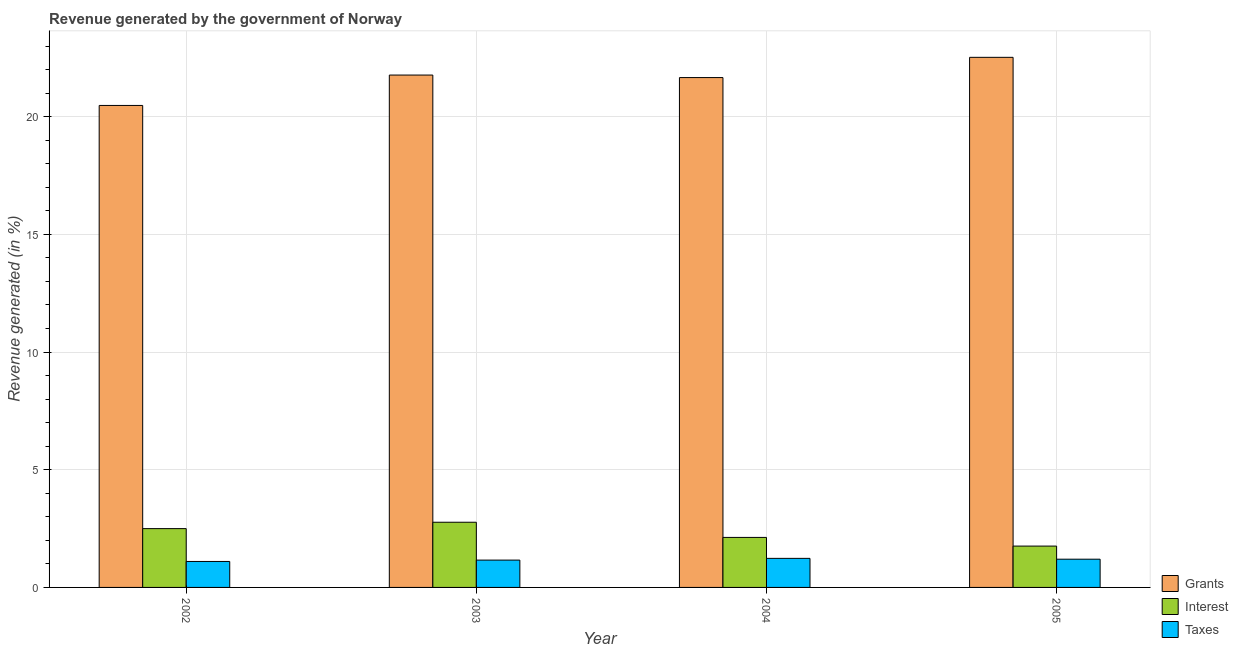How many different coloured bars are there?
Keep it short and to the point. 3. What is the label of the 1st group of bars from the left?
Make the answer very short. 2002. In how many cases, is the number of bars for a given year not equal to the number of legend labels?
Provide a succinct answer. 0. What is the percentage of revenue generated by grants in 2002?
Give a very brief answer. 20.48. Across all years, what is the maximum percentage of revenue generated by grants?
Ensure brevity in your answer.  22.52. Across all years, what is the minimum percentage of revenue generated by taxes?
Offer a very short reply. 1.1. In which year was the percentage of revenue generated by taxes minimum?
Your response must be concise. 2002. What is the total percentage of revenue generated by grants in the graph?
Give a very brief answer. 86.44. What is the difference between the percentage of revenue generated by taxes in 2004 and that in 2005?
Your response must be concise. 0.04. What is the difference between the percentage of revenue generated by interest in 2002 and the percentage of revenue generated by grants in 2004?
Your response must be concise. 0.37. What is the average percentage of revenue generated by taxes per year?
Provide a short and direct response. 1.17. In the year 2003, what is the difference between the percentage of revenue generated by grants and percentage of revenue generated by interest?
Ensure brevity in your answer.  0. What is the ratio of the percentage of revenue generated by grants in 2003 to that in 2004?
Your answer should be compact. 1. Is the percentage of revenue generated by grants in 2002 less than that in 2004?
Your answer should be compact. Yes. What is the difference between the highest and the second highest percentage of revenue generated by taxes?
Offer a terse response. 0.04. What is the difference between the highest and the lowest percentage of revenue generated by interest?
Provide a short and direct response. 1.01. What does the 3rd bar from the left in 2002 represents?
Your answer should be very brief. Taxes. What does the 2nd bar from the right in 2002 represents?
Ensure brevity in your answer.  Interest. How many bars are there?
Offer a very short reply. 12. Are the values on the major ticks of Y-axis written in scientific E-notation?
Make the answer very short. No. Does the graph contain any zero values?
Keep it short and to the point. No. Does the graph contain grids?
Provide a short and direct response. Yes. Where does the legend appear in the graph?
Ensure brevity in your answer.  Bottom right. How many legend labels are there?
Give a very brief answer. 3. What is the title of the graph?
Your answer should be compact. Revenue generated by the government of Norway. Does "Methane" appear as one of the legend labels in the graph?
Provide a short and direct response. No. What is the label or title of the X-axis?
Provide a succinct answer. Year. What is the label or title of the Y-axis?
Give a very brief answer. Revenue generated (in %). What is the Revenue generated (in %) in Grants in 2002?
Provide a short and direct response. 20.48. What is the Revenue generated (in %) in Interest in 2002?
Offer a terse response. 2.5. What is the Revenue generated (in %) in Taxes in 2002?
Your answer should be very brief. 1.1. What is the Revenue generated (in %) of Grants in 2003?
Give a very brief answer. 21.77. What is the Revenue generated (in %) of Interest in 2003?
Give a very brief answer. 2.77. What is the Revenue generated (in %) in Taxes in 2003?
Make the answer very short. 1.16. What is the Revenue generated (in %) in Grants in 2004?
Provide a succinct answer. 21.66. What is the Revenue generated (in %) in Interest in 2004?
Your response must be concise. 2.13. What is the Revenue generated (in %) of Taxes in 2004?
Provide a succinct answer. 1.23. What is the Revenue generated (in %) of Grants in 2005?
Keep it short and to the point. 22.52. What is the Revenue generated (in %) in Interest in 2005?
Your response must be concise. 1.76. What is the Revenue generated (in %) in Taxes in 2005?
Give a very brief answer. 1.2. Across all years, what is the maximum Revenue generated (in %) in Grants?
Your answer should be very brief. 22.52. Across all years, what is the maximum Revenue generated (in %) of Interest?
Offer a terse response. 2.77. Across all years, what is the maximum Revenue generated (in %) of Taxes?
Offer a terse response. 1.23. Across all years, what is the minimum Revenue generated (in %) of Grants?
Provide a short and direct response. 20.48. Across all years, what is the minimum Revenue generated (in %) in Interest?
Give a very brief answer. 1.76. Across all years, what is the minimum Revenue generated (in %) in Taxes?
Offer a very short reply. 1.1. What is the total Revenue generated (in %) of Grants in the graph?
Make the answer very short. 86.44. What is the total Revenue generated (in %) of Interest in the graph?
Ensure brevity in your answer.  9.15. What is the total Revenue generated (in %) in Taxes in the graph?
Offer a very short reply. 4.7. What is the difference between the Revenue generated (in %) of Grants in 2002 and that in 2003?
Your answer should be compact. -1.29. What is the difference between the Revenue generated (in %) of Interest in 2002 and that in 2003?
Make the answer very short. -0.27. What is the difference between the Revenue generated (in %) of Taxes in 2002 and that in 2003?
Keep it short and to the point. -0.06. What is the difference between the Revenue generated (in %) in Grants in 2002 and that in 2004?
Ensure brevity in your answer.  -1.18. What is the difference between the Revenue generated (in %) in Interest in 2002 and that in 2004?
Provide a short and direct response. 0.37. What is the difference between the Revenue generated (in %) in Taxes in 2002 and that in 2004?
Offer a terse response. -0.13. What is the difference between the Revenue generated (in %) in Grants in 2002 and that in 2005?
Provide a short and direct response. -2.04. What is the difference between the Revenue generated (in %) in Interest in 2002 and that in 2005?
Provide a short and direct response. 0.74. What is the difference between the Revenue generated (in %) of Taxes in 2002 and that in 2005?
Your answer should be compact. -0.1. What is the difference between the Revenue generated (in %) in Grants in 2003 and that in 2004?
Give a very brief answer. 0.11. What is the difference between the Revenue generated (in %) of Interest in 2003 and that in 2004?
Make the answer very short. 0.64. What is the difference between the Revenue generated (in %) of Taxes in 2003 and that in 2004?
Provide a succinct answer. -0.07. What is the difference between the Revenue generated (in %) in Grants in 2003 and that in 2005?
Your answer should be compact. -0.75. What is the difference between the Revenue generated (in %) in Taxes in 2003 and that in 2005?
Your answer should be very brief. -0.04. What is the difference between the Revenue generated (in %) in Grants in 2004 and that in 2005?
Provide a succinct answer. -0.86. What is the difference between the Revenue generated (in %) in Interest in 2004 and that in 2005?
Keep it short and to the point. 0.37. What is the difference between the Revenue generated (in %) in Taxes in 2004 and that in 2005?
Offer a terse response. 0.04. What is the difference between the Revenue generated (in %) of Grants in 2002 and the Revenue generated (in %) of Interest in 2003?
Keep it short and to the point. 17.71. What is the difference between the Revenue generated (in %) in Grants in 2002 and the Revenue generated (in %) in Taxes in 2003?
Your answer should be compact. 19.32. What is the difference between the Revenue generated (in %) of Interest in 2002 and the Revenue generated (in %) of Taxes in 2003?
Give a very brief answer. 1.34. What is the difference between the Revenue generated (in %) in Grants in 2002 and the Revenue generated (in %) in Interest in 2004?
Provide a succinct answer. 18.35. What is the difference between the Revenue generated (in %) in Grants in 2002 and the Revenue generated (in %) in Taxes in 2004?
Make the answer very short. 19.24. What is the difference between the Revenue generated (in %) in Interest in 2002 and the Revenue generated (in %) in Taxes in 2004?
Provide a succinct answer. 1.26. What is the difference between the Revenue generated (in %) in Grants in 2002 and the Revenue generated (in %) in Interest in 2005?
Make the answer very short. 18.72. What is the difference between the Revenue generated (in %) of Grants in 2002 and the Revenue generated (in %) of Taxes in 2005?
Your answer should be compact. 19.28. What is the difference between the Revenue generated (in %) in Interest in 2002 and the Revenue generated (in %) in Taxes in 2005?
Offer a very short reply. 1.3. What is the difference between the Revenue generated (in %) in Grants in 2003 and the Revenue generated (in %) in Interest in 2004?
Make the answer very short. 19.64. What is the difference between the Revenue generated (in %) in Grants in 2003 and the Revenue generated (in %) in Taxes in 2004?
Make the answer very short. 20.54. What is the difference between the Revenue generated (in %) in Interest in 2003 and the Revenue generated (in %) in Taxes in 2004?
Make the answer very short. 1.54. What is the difference between the Revenue generated (in %) of Grants in 2003 and the Revenue generated (in %) of Interest in 2005?
Make the answer very short. 20.01. What is the difference between the Revenue generated (in %) of Grants in 2003 and the Revenue generated (in %) of Taxes in 2005?
Provide a succinct answer. 20.57. What is the difference between the Revenue generated (in %) of Interest in 2003 and the Revenue generated (in %) of Taxes in 2005?
Your response must be concise. 1.57. What is the difference between the Revenue generated (in %) of Grants in 2004 and the Revenue generated (in %) of Interest in 2005?
Keep it short and to the point. 19.91. What is the difference between the Revenue generated (in %) in Grants in 2004 and the Revenue generated (in %) in Taxes in 2005?
Your response must be concise. 20.46. What is the difference between the Revenue generated (in %) of Interest in 2004 and the Revenue generated (in %) of Taxes in 2005?
Your answer should be compact. 0.93. What is the average Revenue generated (in %) of Grants per year?
Offer a very short reply. 21.61. What is the average Revenue generated (in %) of Interest per year?
Ensure brevity in your answer.  2.29. What is the average Revenue generated (in %) in Taxes per year?
Ensure brevity in your answer.  1.17. In the year 2002, what is the difference between the Revenue generated (in %) of Grants and Revenue generated (in %) of Interest?
Offer a terse response. 17.98. In the year 2002, what is the difference between the Revenue generated (in %) of Grants and Revenue generated (in %) of Taxes?
Offer a terse response. 19.38. In the year 2002, what is the difference between the Revenue generated (in %) of Interest and Revenue generated (in %) of Taxes?
Provide a short and direct response. 1.4. In the year 2003, what is the difference between the Revenue generated (in %) of Grants and Revenue generated (in %) of Interest?
Your answer should be very brief. 19. In the year 2003, what is the difference between the Revenue generated (in %) in Grants and Revenue generated (in %) in Taxes?
Provide a succinct answer. 20.61. In the year 2003, what is the difference between the Revenue generated (in %) in Interest and Revenue generated (in %) in Taxes?
Keep it short and to the point. 1.61. In the year 2004, what is the difference between the Revenue generated (in %) in Grants and Revenue generated (in %) in Interest?
Your answer should be very brief. 19.54. In the year 2004, what is the difference between the Revenue generated (in %) of Grants and Revenue generated (in %) of Taxes?
Provide a succinct answer. 20.43. In the year 2004, what is the difference between the Revenue generated (in %) in Interest and Revenue generated (in %) in Taxes?
Ensure brevity in your answer.  0.89. In the year 2005, what is the difference between the Revenue generated (in %) in Grants and Revenue generated (in %) in Interest?
Provide a short and direct response. 20.77. In the year 2005, what is the difference between the Revenue generated (in %) of Grants and Revenue generated (in %) of Taxes?
Make the answer very short. 21.32. In the year 2005, what is the difference between the Revenue generated (in %) of Interest and Revenue generated (in %) of Taxes?
Your answer should be compact. 0.56. What is the ratio of the Revenue generated (in %) of Grants in 2002 to that in 2003?
Offer a terse response. 0.94. What is the ratio of the Revenue generated (in %) in Interest in 2002 to that in 2003?
Your answer should be compact. 0.9. What is the ratio of the Revenue generated (in %) of Taxes in 2002 to that in 2003?
Your answer should be compact. 0.95. What is the ratio of the Revenue generated (in %) in Grants in 2002 to that in 2004?
Your response must be concise. 0.95. What is the ratio of the Revenue generated (in %) in Interest in 2002 to that in 2004?
Make the answer very short. 1.18. What is the ratio of the Revenue generated (in %) of Taxes in 2002 to that in 2004?
Keep it short and to the point. 0.89. What is the ratio of the Revenue generated (in %) in Grants in 2002 to that in 2005?
Your response must be concise. 0.91. What is the ratio of the Revenue generated (in %) of Interest in 2002 to that in 2005?
Make the answer very short. 1.42. What is the ratio of the Revenue generated (in %) of Taxes in 2002 to that in 2005?
Your response must be concise. 0.92. What is the ratio of the Revenue generated (in %) in Interest in 2003 to that in 2004?
Keep it short and to the point. 1.3. What is the ratio of the Revenue generated (in %) of Taxes in 2003 to that in 2004?
Offer a terse response. 0.94. What is the ratio of the Revenue generated (in %) in Grants in 2003 to that in 2005?
Provide a short and direct response. 0.97. What is the ratio of the Revenue generated (in %) in Interest in 2003 to that in 2005?
Your answer should be very brief. 1.58. What is the ratio of the Revenue generated (in %) in Taxes in 2003 to that in 2005?
Make the answer very short. 0.97. What is the ratio of the Revenue generated (in %) in Grants in 2004 to that in 2005?
Keep it short and to the point. 0.96. What is the ratio of the Revenue generated (in %) of Interest in 2004 to that in 2005?
Give a very brief answer. 1.21. What is the ratio of the Revenue generated (in %) in Taxes in 2004 to that in 2005?
Offer a very short reply. 1.03. What is the difference between the highest and the second highest Revenue generated (in %) of Grants?
Keep it short and to the point. 0.75. What is the difference between the highest and the second highest Revenue generated (in %) of Interest?
Your answer should be compact. 0.27. What is the difference between the highest and the second highest Revenue generated (in %) in Taxes?
Offer a very short reply. 0.04. What is the difference between the highest and the lowest Revenue generated (in %) of Grants?
Your answer should be compact. 2.04. What is the difference between the highest and the lowest Revenue generated (in %) of Interest?
Give a very brief answer. 1.01. What is the difference between the highest and the lowest Revenue generated (in %) of Taxes?
Offer a very short reply. 0.13. 